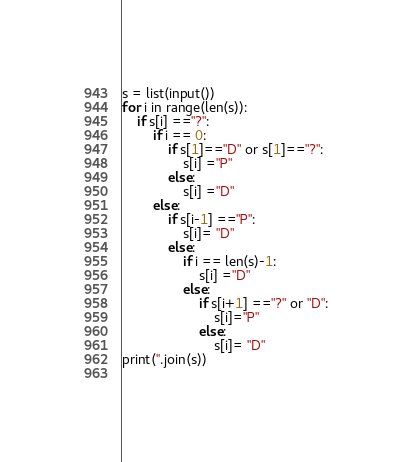Convert code to text. <code><loc_0><loc_0><loc_500><loc_500><_Python_>s = list(input())
for i in range(len(s)):
    if s[i] =="?":
        if i == 0:
            if s[1]=="D" or s[1]=="?":
                s[i] ="P"
            else:
                s[i] ="D"
        else:
            if s[i-1] =="P":
                s[i]= "D"
            else:
                if i == len(s)-1:
                    s[i] ="D"
                else:
                    if s[i+1] =="?" or "D":
                        s[i]="P"
                    else:
                        s[i]= "D"
print(''.join(s))
            </code> 